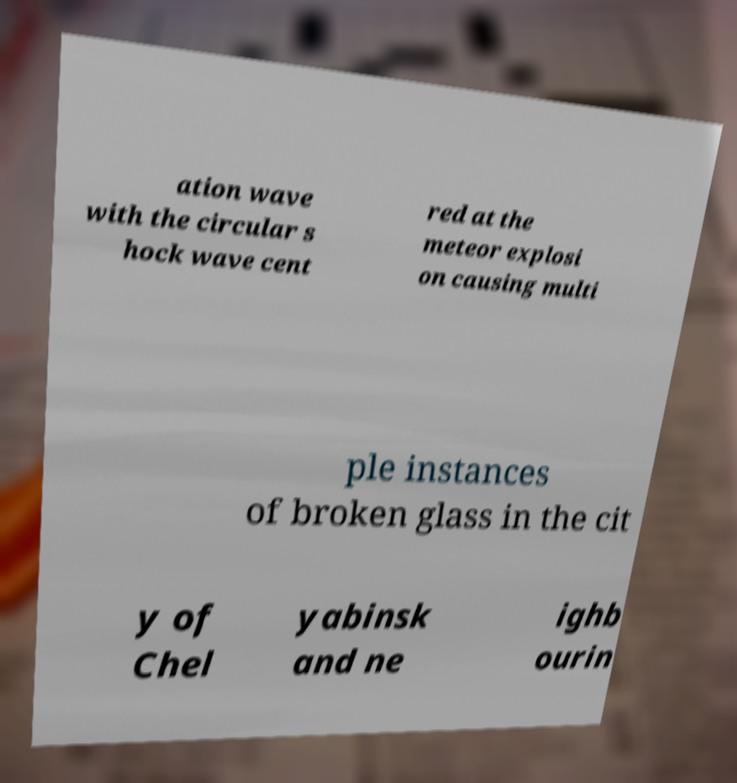Could you assist in decoding the text presented in this image and type it out clearly? ation wave with the circular s hock wave cent red at the meteor explosi on causing multi ple instances of broken glass in the cit y of Chel yabinsk and ne ighb ourin 